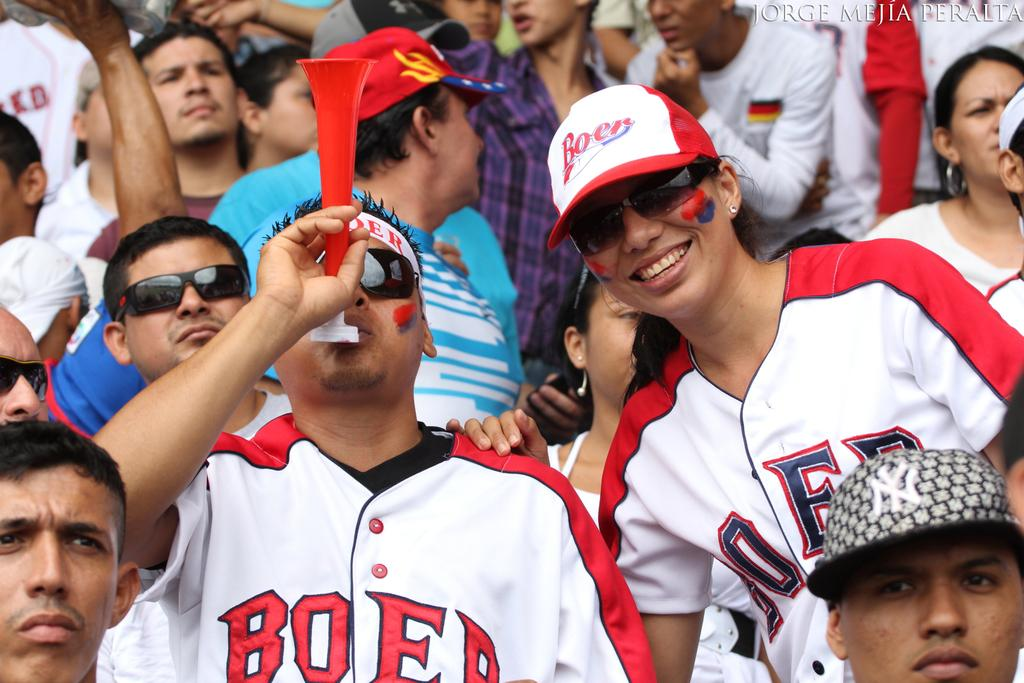<image>
Provide a brief description of the given image. man wearing boer jersey blowing horn as woman stands next to him 